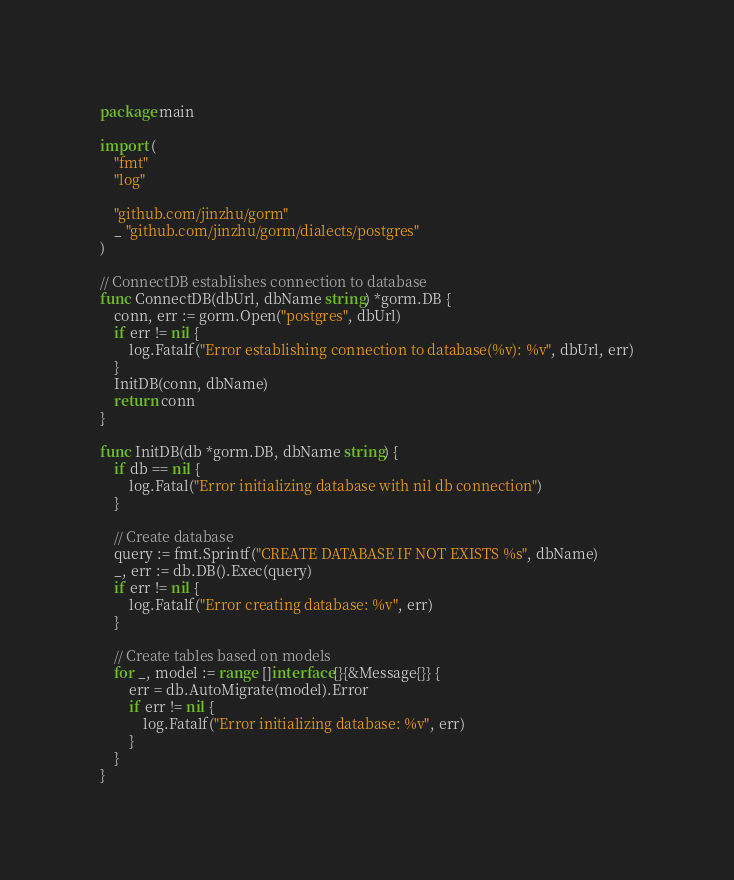Convert code to text. <code><loc_0><loc_0><loc_500><loc_500><_Go_>package main

import (
	"fmt"
	"log"

	"github.com/jinzhu/gorm"
	_ "github.com/jinzhu/gorm/dialects/postgres"
)

// ConnectDB establishes connection to database
func ConnectDB(dbUrl, dbName string) *gorm.DB {
	conn, err := gorm.Open("postgres", dbUrl)
	if err != nil {
		log.Fatalf("Error establishing connection to database(%v): %v", dbUrl, err)
	}
	InitDB(conn, dbName)
	return conn
}

func InitDB(db *gorm.DB, dbName string) {
	if db == nil {
		log.Fatal("Error initializing database with nil db connection")
	}

	// Create database
	query := fmt.Sprintf("CREATE DATABASE IF NOT EXISTS %s", dbName)
	_, err := db.DB().Exec(query)
	if err != nil {
		log.Fatalf("Error creating database: %v", err)
	}

	// Create tables based on models
	for _, model := range []interface{}{&Message{}} {
		err = db.AutoMigrate(model).Error
		if err != nil {
			log.Fatalf("Error initializing database: %v", err)
		}
	}
}
</code> 